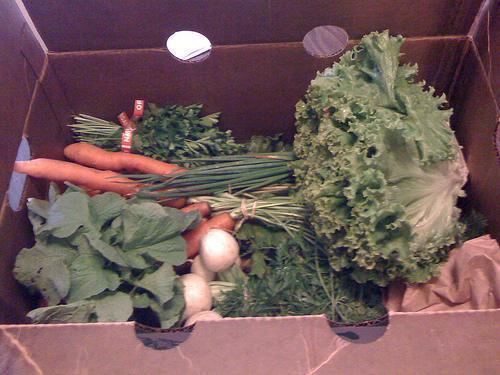How many heads of lettuce are there?
Give a very brief answer. 1. 